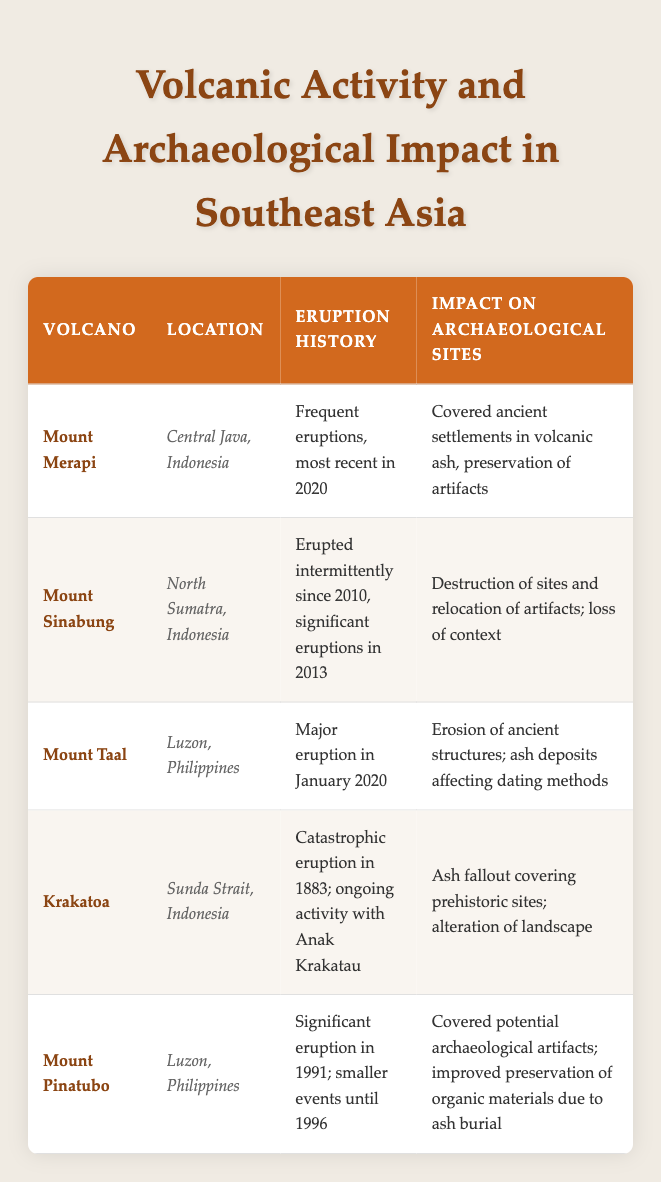What is the location of Mount Merapi? Mount Merapi is listed in the table along with its location, which is specifically noted as "Central Java, Indonesia."
Answer: Central Java, Indonesia Which volcano had a significant eruption in 1991? The table indicates that Mount Pinatubo had a significant eruption in 1991, as stated in its eruption history.
Answer: Mount Pinatubo True or False: Mount Sinabung has only erupted once since 2010. The table describes Mount Sinabung as having erupted intermittently since 2010, with significant eruptions noted in 2013, indicating that it has erupted multiple times, not just once.
Answer: False How many volcanic sites mentioned in the table have impacts leading to the preservation of artifacts? Looking through the table, Mount Merapi and Mount Pinatubo both have impacts that suggest preservation of artifacts, with their descriptions noting preservation due to volcanic ash. There are two such sites.
Answer: 2 What is the average eruption year of the volcanoes mentioned in the table? According to the eruption history, Mount Merapi erupted in 2020, Mount Sinabung's significant eruption was in 2013, Mount Taal in 2020, Krakatoa's catastrophic eruption was in 1883, and Mount Pinatubo in 1991. Adding these years gives us (2020 + 2013 + 2020 + 1883 + 1991) = 10127. Dividing by 5 gives us an average year of 2025.4, or considering only the recorded eruptions, we find an average eruption year of around 1998.
Answer: 1998 Which volcanoes had eruption impacts that led to the destruction of archaeological sites? The table shows that only Mount Sinabung had a noted impact of destruction of sites and loss of context due to its eruptions. The relevant information in the impact column confirms this.
Answer: Mount Sinabung 